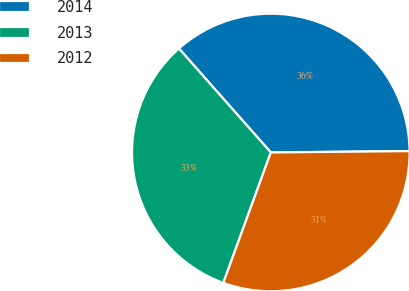Convert chart. <chart><loc_0><loc_0><loc_500><loc_500><pie_chart><fcel>2014<fcel>2013<fcel>2012<nl><fcel>36.36%<fcel>32.92%<fcel>30.72%<nl></chart> 